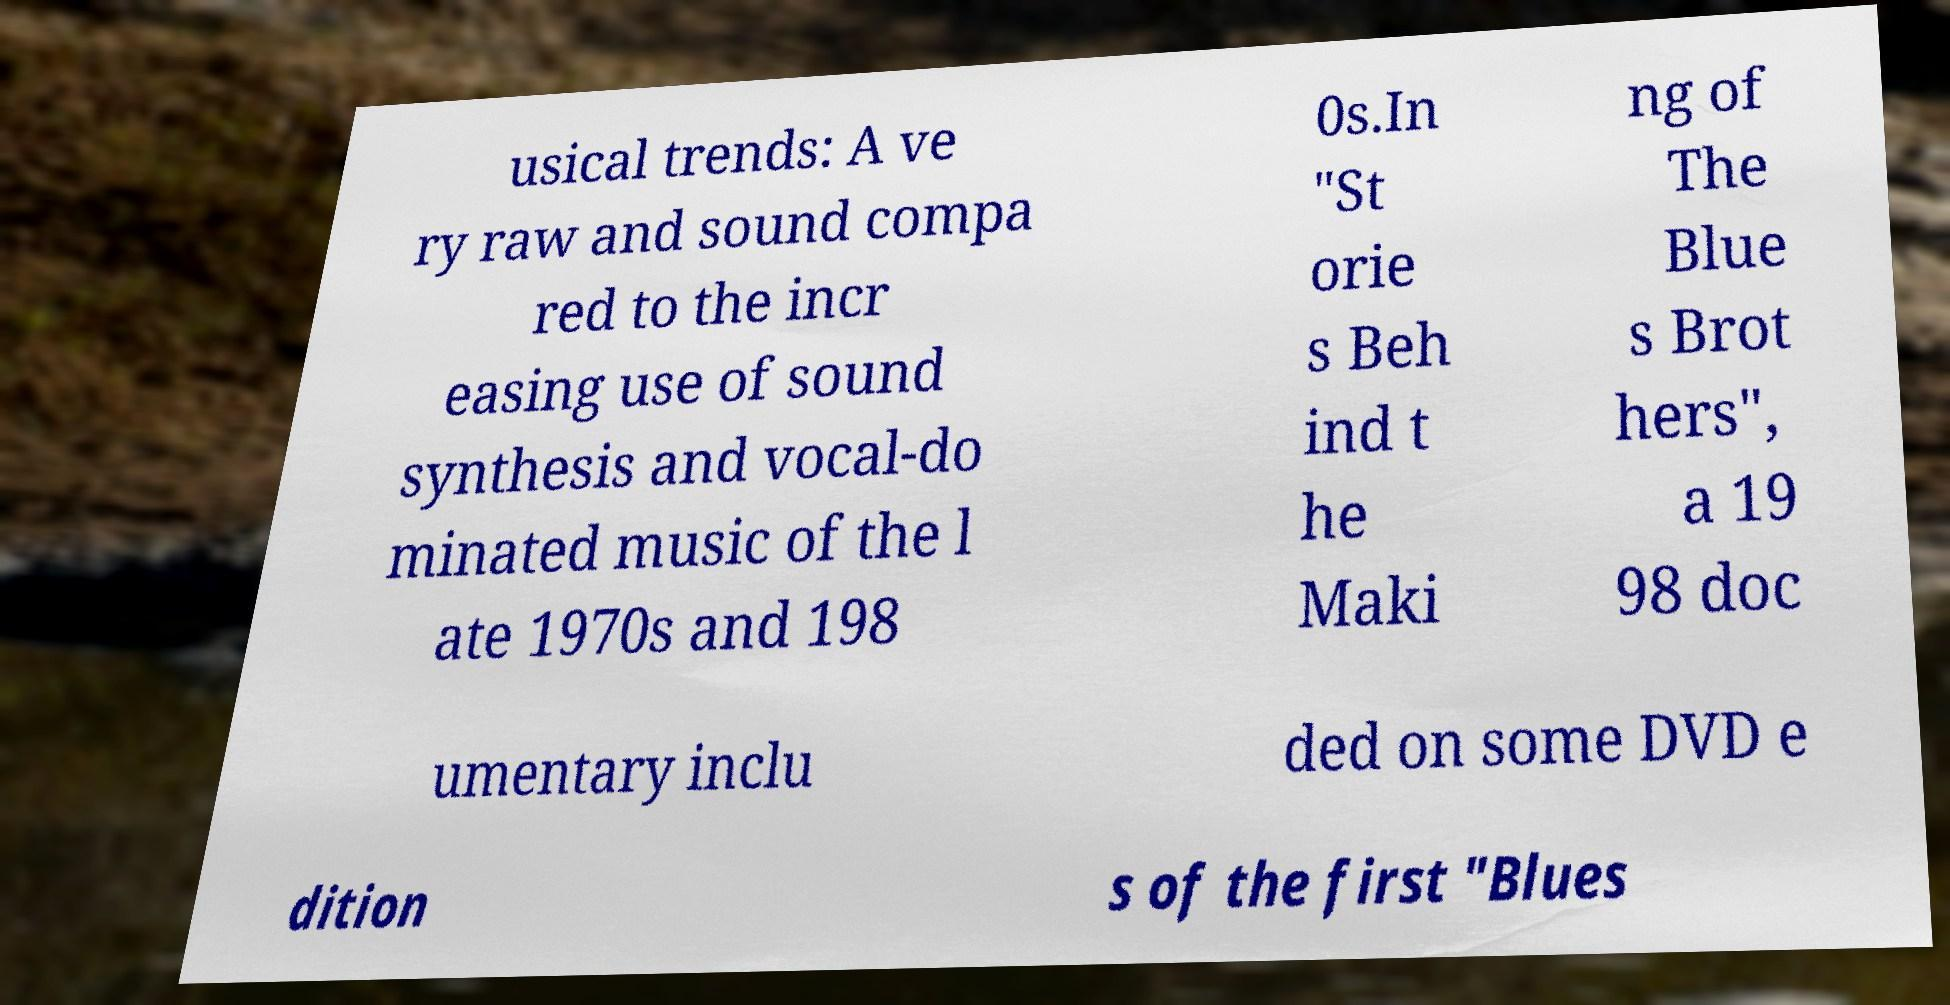Could you assist in decoding the text presented in this image and type it out clearly? usical trends: A ve ry raw and sound compa red to the incr easing use of sound synthesis and vocal-do minated music of the l ate 1970s and 198 0s.In "St orie s Beh ind t he Maki ng of The Blue s Brot hers", a 19 98 doc umentary inclu ded on some DVD e dition s of the first "Blues 